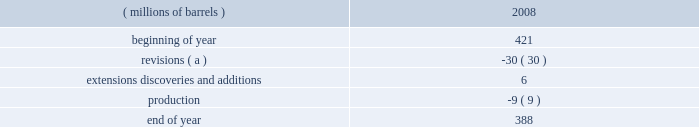Proved reserves can be added as expansions are permitted , funding is approved and certain stipulations of the joint venture agreement are satisfied .
The table sets forth changes in estimated quantities of net proved bitumen reserves for the year 2008 .
Estimated quantities of proved bitumen reserves ( millions of barrels ) 2008 .
( a ) revisions were driven primarily by price and the impact of the new royalty regime discussed below .
The above estimated quantity of net proved bitumen reserves is a forward-looking statement and is based on a number of assumptions , including ( among others ) commodity prices , volumes in-place , presently known physical data , recoverability of bitumen , industry economic conditions , levels of cash flow from operations , and other operating considerations .
To the extent these assumptions prove inaccurate , actual recoveries could be different than current estimates .
For a discussion of the proved bitumen reserves estimation process , see item 7 .
Management 2019s discussion and analysis of financial condition and results of operations 2013 critical accounting estimates 2013 estimated net recoverable reserve quantities 2013 proved bitumen reserves .
Operations at the aosp are not within the scope of statement of financial accounting standards ( 201csfas 201d ) no .
25 , 201csuspension of certain accounting requirements for oil and gas producing companies ( an amendment of financial accounting standards board ( 201cfasb 201d ) statement no .
19 ) , 201d sfas no .
69 , 201cdisclosures about oil and gas producing activities ( an amendment of fasb statements 19 , 25 , 33 and 39 ) , 201d and securities and exchange commission ( 201csec 201d ) rule 4-10 of regulation s-x ; therefore , bitumen production and reserves are not included in our supplementary information on oil and gas producing activities .
The sec has recently issued a release amending these disclosure requirements effective for annual reports on form 10-k for fiscal years ending on or after december 31 , 2009 , see item 7 .
Management 2019s discussion and analysis of financial condition and results of operations 2013 accounting standards not yet adopted for additional information .
Prior to our acquisition of western , the first fully-integrated expansion of the existing aosp facilities was approved in 2006 .
Expansion 1 , which includes construction of mining and extraction facilities at the jackpine mine , expansion of treatment facilities at the existing muskeg river mine , expansion of the scotford upgrader and development of related infrastructure , is anticipated to begin operations in late 2010 or 2011 .
When expansion 1 is complete , we will have more than 50000 bpd of net production and upgrading capacity in the canadian oil sands .
The timing and scope of future expansions and debottlenecking opportunities on existing operations remain under review .
During 2008 , the alberta government accepted the project 2019s application to have a portion of the expansion 1 capital costs form part of the muskeg river mine 2019s allowable cost recovery pool .
Due to commodity price declines in the year , royalties for 2008 were one percent of the gross mine revenue .
Commencing january 1 , 2009 , the alberta royalty regime has been amended such that royalty rates will be based on the canadian dollar ( 201ccad 201d ) equivalent monthly average west texas intermediate ( 201cwti 201d ) price .
Royalty rates will rise from a minimum of one percent to a maximum of nine percent under the gross revenue method and from a minimum of 25 percent to a maximum of 40 percent under the net revenue method .
Under both methods , the minimum royalty is based on a wti price of $ 55.00 cad per barrel and below while the maximum royalty is reached at a wti price of $ 120.00 cad per barrel and above , with a linear increase in royalty between the aforementioned prices .
The above discussion of the oil sands mining segment includes forward-looking statements concerning the anticipated completion of aosp expansion 1 .
Factors which could affect the expansion project include transportation logistics , availability of materials and labor , unforeseen hazards such as weather conditions , delays in obtaining or conditions imposed by necessary government and third-party approvals and other risks customarily associated with construction projects .
Refining , marketing and transportation refining we own and operate seven refineries in the gulf coast , midwest and upper great plains regions of the united states with an aggregate refining capacity of 1.016 million barrels per day ( 201cmmbpd 201d ) of crude oil .
During 2008 .
Of the ending 2008 balance of proved bitumen reserves what percentage makes up extensions discoveries and additions? 
Computations: (6 / 388)
Answer: 0.01546. Proved reserves can be added as expansions are permitted , funding is approved and certain stipulations of the joint venture agreement are satisfied .
The table sets forth changes in estimated quantities of net proved bitumen reserves for the year 2008 .
Estimated quantities of proved bitumen reserves ( millions of barrels ) 2008 .
( a ) revisions were driven primarily by price and the impact of the new royalty regime discussed below .
The above estimated quantity of net proved bitumen reserves is a forward-looking statement and is based on a number of assumptions , including ( among others ) commodity prices , volumes in-place , presently known physical data , recoverability of bitumen , industry economic conditions , levels of cash flow from operations , and other operating considerations .
To the extent these assumptions prove inaccurate , actual recoveries could be different than current estimates .
For a discussion of the proved bitumen reserves estimation process , see item 7 .
Management 2019s discussion and analysis of financial condition and results of operations 2013 critical accounting estimates 2013 estimated net recoverable reserve quantities 2013 proved bitumen reserves .
Operations at the aosp are not within the scope of statement of financial accounting standards ( 201csfas 201d ) no .
25 , 201csuspension of certain accounting requirements for oil and gas producing companies ( an amendment of financial accounting standards board ( 201cfasb 201d ) statement no .
19 ) , 201d sfas no .
69 , 201cdisclosures about oil and gas producing activities ( an amendment of fasb statements 19 , 25 , 33 and 39 ) , 201d and securities and exchange commission ( 201csec 201d ) rule 4-10 of regulation s-x ; therefore , bitumen production and reserves are not included in our supplementary information on oil and gas producing activities .
The sec has recently issued a release amending these disclosure requirements effective for annual reports on form 10-k for fiscal years ending on or after december 31 , 2009 , see item 7 .
Management 2019s discussion and analysis of financial condition and results of operations 2013 accounting standards not yet adopted for additional information .
Prior to our acquisition of western , the first fully-integrated expansion of the existing aosp facilities was approved in 2006 .
Expansion 1 , which includes construction of mining and extraction facilities at the jackpine mine , expansion of treatment facilities at the existing muskeg river mine , expansion of the scotford upgrader and development of related infrastructure , is anticipated to begin operations in late 2010 or 2011 .
When expansion 1 is complete , we will have more than 50000 bpd of net production and upgrading capacity in the canadian oil sands .
The timing and scope of future expansions and debottlenecking opportunities on existing operations remain under review .
During 2008 , the alberta government accepted the project 2019s application to have a portion of the expansion 1 capital costs form part of the muskeg river mine 2019s allowable cost recovery pool .
Due to commodity price declines in the year , royalties for 2008 were one percent of the gross mine revenue .
Commencing january 1 , 2009 , the alberta royalty regime has been amended such that royalty rates will be based on the canadian dollar ( 201ccad 201d ) equivalent monthly average west texas intermediate ( 201cwti 201d ) price .
Royalty rates will rise from a minimum of one percent to a maximum of nine percent under the gross revenue method and from a minimum of 25 percent to a maximum of 40 percent under the net revenue method .
Under both methods , the minimum royalty is based on a wti price of $ 55.00 cad per barrel and below while the maximum royalty is reached at a wti price of $ 120.00 cad per barrel and above , with a linear increase in royalty between the aforementioned prices .
The above discussion of the oil sands mining segment includes forward-looking statements concerning the anticipated completion of aosp expansion 1 .
Factors which could affect the expansion project include transportation logistics , availability of materials and labor , unforeseen hazards such as weather conditions , delays in obtaining or conditions imposed by necessary government and third-party approvals and other risks customarily associated with construction projects .
Refining , marketing and transportation refining we own and operate seven refineries in the gulf coast , midwest and upper great plains regions of the united states with an aggregate refining capacity of 1.016 million barrels per day ( 201cmmbpd 201d ) of crude oil .
During 2008 .
In ( millions of barrels ) , what was the average of beginning and end of year reserves? 
Computations: ((421 + 388) / 2)
Answer: 404.5. 